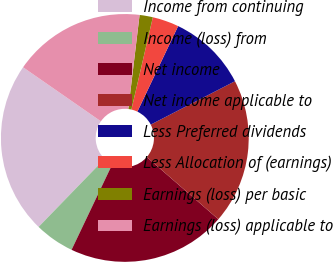<chart> <loc_0><loc_0><loc_500><loc_500><pie_chart><fcel>Income from continuing<fcel>Income (loss) from<fcel>Net income<fcel>Net income applicable to<fcel>Less Preferred dividends<fcel>Less Allocation of (earnings)<fcel>Earnings (loss) per basic<fcel>Earnings (loss) applicable to<nl><fcel>22.41%<fcel>5.18%<fcel>20.68%<fcel>18.96%<fcel>10.35%<fcel>3.45%<fcel>1.73%<fcel>17.24%<nl></chart> 